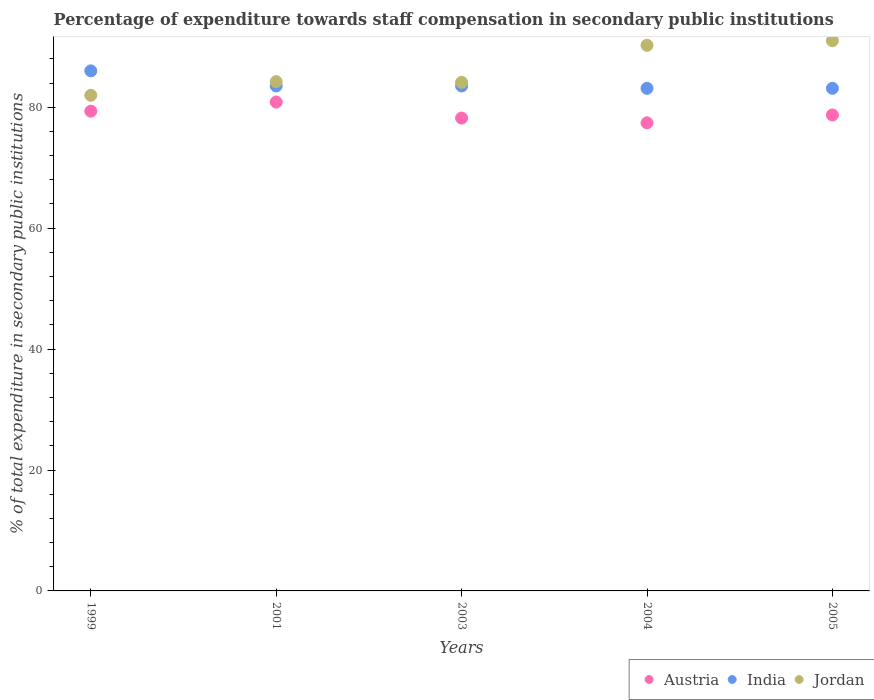What is the percentage of expenditure towards staff compensation in India in 1999?
Your answer should be very brief. 86.02. Across all years, what is the maximum percentage of expenditure towards staff compensation in Jordan?
Keep it short and to the point. 91.01. Across all years, what is the minimum percentage of expenditure towards staff compensation in Jordan?
Offer a terse response. 81.99. In which year was the percentage of expenditure towards staff compensation in Austria maximum?
Ensure brevity in your answer.  2001. In which year was the percentage of expenditure towards staff compensation in India minimum?
Make the answer very short. 2004. What is the total percentage of expenditure towards staff compensation in Austria in the graph?
Give a very brief answer. 394.57. What is the difference between the percentage of expenditure towards staff compensation in Jordan in 2001 and that in 2003?
Keep it short and to the point. 0.11. What is the difference between the percentage of expenditure towards staff compensation in Austria in 1999 and the percentage of expenditure towards staff compensation in Jordan in 2005?
Give a very brief answer. -11.66. What is the average percentage of expenditure towards staff compensation in Jordan per year?
Provide a short and direct response. 86.32. In the year 1999, what is the difference between the percentage of expenditure towards staff compensation in India and percentage of expenditure towards staff compensation in Austria?
Keep it short and to the point. 6.67. What is the ratio of the percentage of expenditure towards staff compensation in Jordan in 1999 to that in 2003?
Give a very brief answer. 0.97. Is the percentage of expenditure towards staff compensation in Austria in 1999 less than that in 2004?
Ensure brevity in your answer.  No. Is the difference between the percentage of expenditure towards staff compensation in India in 1999 and 2001 greater than the difference between the percentage of expenditure towards staff compensation in Austria in 1999 and 2001?
Keep it short and to the point. Yes. What is the difference between the highest and the second highest percentage of expenditure towards staff compensation in Jordan?
Ensure brevity in your answer.  0.77. What is the difference between the highest and the lowest percentage of expenditure towards staff compensation in Austria?
Ensure brevity in your answer.  3.44. Is the sum of the percentage of expenditure towards staff compensation in Austria in 2003 and 2004 greater than the maximum percentage of expenditure towards staff compensation in India across all years?
Ensure brevity in your answer.  Yes. Is it the case that in every year, the sum of the percentage of expenditure towards staff compensation in Jordan and percentage of expenditure towards staff compensation in India  is greater than the percentage of expenditure towards staff compensation in Austria?
Make the answer very short. Yes. Are the values on the major ticks of Y-axis written in scientific E-notation?
Give a very brief answer. No. Does the graph contain any zero values?
Offer a very short reply. No. Does the graph contain grids?
Give a very brief answer. No. How many legend labels are there?
Offer a terse response. 3. How are the legend labels stacked?
Keep it short and to the point. Horizontal. What is the title of the graph?
Keep it short and to the point. Percentage of expenditure towards staff compensation in secondary public institutions. What is the label or title of the Y-axis?
Provide a succinct answer. % of total expenditure in secondary public institutions. What is the % of total expenditure in secondary public institutions in Austria in 1999?
Your answer should be very brief. 79.35. What is the % of total expenditure in secondary public institutions of India in 1999?
Make the answer very short. 86.02. What is the % of total expenditure in secondary public institutions in Jordan in 1999?
Make the answer very short. 81.99. What is the % of total expenditure in secondary public institutions in Austria in 2001?
Keep it short and to the point. 80.86. What is the % of total expenditure in secondary public institutions of India in 2001?
Your answer should be very brief. 83.52. What is the % of total expenditure in secondary public institutions in Jordan in 2001?
Give a very brief answer. 84.24. What is the % of total expenditure in secondary public institutions in Austria in 2003?
Your response must be concise. 78.21. What is the % of total expenditure in secondary public institutions of India in 2003?
Your answer should be very brief. 83.52. What is the % of total expenditure in secondary public institutions of Jordan in 2003?
Keep it short and to the point. 84.13. What is the % of total expenditure in secondary public institutions in Austria in 2004?
Provide a short and direct response. 77.43. What is the % of total expenditure in secondary public institutions in India in 2004?
Keep it short and to the point. 83.13. What is the % of total expenditure in secondary public institutions in Jordan in 2004?
Provide a short and direct response. 90.25. What is the % of total expenditure in secondary public institutions of Austria in 2005?
Give a very brief answer. 78.72. What is the % of total expenditure in secondary public institutions in India in 2005?
Your response must be concise. 83.13. What is the % of total expenditure in secondary public institutions of Jordan in 2005?
Your answer should be compact. 91.01. Across all years, what is the maximum % of total expenditure in secondary public institutions in Austria?
Offer a terse response. 80.86. Across all years, what is the maximum % of total expenditure in secondary public institutions of India?
Make the answer very short. 86.02. Across all years, what is the maximum % of total expenditure in secondary public institutions of Jordan?
Offer a terse response. 91.01. Across all years, what is the minimum % of total expenditure in secondary public institutions in Austria?
Offer a very short reply. 77.43. Across all years, what is the minimum % of total expenditure in secondary public institutions of India?
Your answer should be very brief. 83.13. Across all years, what is the minimum % of total expenditure in secondary public institutions in Jordan?
Provide a succinct answer. 81.99. What is the total % of total expenditure in secondary public institutions of Austria in the graph?
Your answer should be compact. 394.57. What is the total % of total expenditure in secondary public institutions in India in the graph?
Your answer should be very brief. 419.33. What is the total % of total expenditure in secondary public institutions of Jordan in the graph?
Provide a succinct answer. 431.61. What is the difference between the % of total expenditure in secondary public institutions in Austria in 1999 and that in 2001?
Keep it short and to the point. -1.51. What is the difference between the % of total expenditure in secondary public institutions of India in 1999 and that in 2001?
Your response must be concise. 2.5. What is the difference between the % of total expenditure in secondary public institutions of Jordan in 1999 and that in 2001?
Make the answer very short. -2.25. What is the difference between the % of total expenditure in secondary public institutions in Austria in 1999 and that in 2003?
Provide a short and direct response. 1.14. What is the difference between the % of total expenditure in secondary public institutions of India in 1999 and that in 2003?
Your response must be concise. 2.5. What is the difference between the % of total expenditure in secondary public institutions in Jordan in 1999 and that in 2003?
Make the answer very short. -2.14. What is the difference between the % of total expenditure in secondary public institutions in Austria in 1999 and that in 2004?
Keep it short and to the point. 1.93. What is the difference between the % of total expenditure in secondary public institutions in India in 1999 and that in 2004?
Your answer should be compact. 2.89. What is the difference between the % of total expenditure in secondary public institutions of Jordan in 1999 and that in 2004?
Your answer should be compact. -8.26. What is the difference between the % of total expenditure in secondary public institutions of Austria in 1999 and that in 2005?
Your response must be concise. 0.63. What is the difference between the % of total expenditure in secondary public institutions of India in 1999 and that in 2005?
Ensure brevity in your answer.  2.89. What is the difference between the % of total expenditure in secondary public institutions in Jordan in 1999 and that in 2005?
Your answer should be compact. -9.03. What is the difference between the % of total expenditure in secondary public institutions of Austria in 2001 and that in 2003?
Provide a short and direct response. 2.65. What is the difference between the % of total expenditure in secondary public institutions in India in 2001 and that in 2003?
Your answer should be compact. 0. What is the difference between the % of total expenditure in secondary public institutions of Jordan in 2001 and that in 2003?
Keep it short and to the point. 0.11. What is the difference between the % of total expenditure in secondary public institutions of Austria in 2001 and that in 2004?
Your answer should be compact. 3.44. What is the difference between the % of total expenditure in secondary public institutions in India in 2001 and that in 2004?
Provide a succinct answer. 0.39. What is the difference between the % of total expenditure in secondary public institutions in Jordan in 2001 and that in 2004?
Your response must be concise. -6.01. What is the difference between the % of total expenditure in secondary public institutions in Austria in 2001 and that in 2005?
Give a very brief answer. 2.14. What is the difference between the % of total expenditure in secondary public institutions of India in 2001 and that in 2005?
Your answer should be very brief. 0.39. What is the difference between the % of total expenditure in secondary public institutions of Jordan in 2001 and that in 2005?
Provide a short and direct response. -6.78. What is the difference between the % of total expenditure in secondary public institutions in Austria in 2003 and that in 2004?
Ensure brevity in your answer.  0.79. What is the difference between the % of total expenditure in secondary public institutions in India in 2003 and that in 2004?
Keep it short and to the point. 0.39. What is the difference between the % of total expenditure in secondary public institutions in Jordan in 2003 and that in 2004?
Your response must be concise. -6.12. What is the difference between the % of total expenditure in secondary public institutions in Austria in 2003 and that in 2005?
Keep it short and to the point. -0.51. What is the difference between the % of total expenditure in secondary public institutions in India in 2003 and that in 2005?
Provide a succinct answer. 0.39. What is the difference between the % of total expenditure in secondary public institutions in Jordan in 2003 and that in 2005?
Provide a short and direct response. -6.89. What is the difference between the % of total expenditure in secondary public institutions of Austria in 2004 and that in 2005?
Ensure brevity in your answer.  -1.3. What is the difference between the % of total expenditure in secondary public institutions of Jordan in 2004 and that in 2005?
Keep it short and to the point. -0.77. What is the difference between the % of total expenditure in secondary public institutions in Austria in 1999 and the % of total expenditure in secondary public institutions in India in 2001?
Keep it short and to the point. -4.17. What is the difference between the % of total expenditure in secondary public institutions in Austria in 1999 and the % of total expenditure in secondary public institutions in Jordan in 2001?
Offer a terse response. -4.88. What is the difference between the % of total expenditure in secondary public institutions in India in 1999 and the % of total expenditure in secondary public institutions in Jordan in 2001?
Ensure brevity in your answer.  1.78. What is the difference between the % of total expenditure in secondary public institutions in Austria in 1999 and the % of total expenditure in secondary public institutions in India in 2003?
Your answer should be compact. -4.17. What is the difference between the % of total expenditure in secondary public institutions of Austria in 1999 and the % of total expenditure in secondary public institutions of Jordan in 2003?
Ensure brevity in your answer.  -4.77. What is the difference between the % of total expenditure in secondary public institutions in India in 1999 and the % of total expenditure in secondary public institutions in Jordan in 2003?
Offer a very short reply. 1.9. What is the difference between the % of total expenditure in secondary public institutions in Austria in 1999 and the % of total expenditure in secondary public institutions in India in 2004?
Keep it short and to the point. -3.78. What is the difference between the % of total expenditure in secondary public institutions of Austria in 1999 and the % of total expenditure in secondary public institutions of Jordan in 2004?
Keep it short and to the point. -10.89. What is the difference between the % of total expenditure in secondary public institutions of India in 1999 and the % of total expenditure in secondary public institutions of Jordan in 2004?
Keep it short and to the point. -4.23. What is the difference between the % of total expenditure in secondary public institutions of Austria in 1999 and the % of total expenditure in secondary public institutions of India in 2005?
Provide a succinct answer. -3.78. What is the difference between the % of total expenditure in secondary public institutions of Austria in 1999 and the % of total expenditure in secondary public institutions of Jordan in 2005?
Provide a short and direct response. -11.66. What is the difference between the % of total expenditure in secondary public institutions in India in 1999 and the % of total expenditure in secondary public institutions in Jordan in 2005?
Your answer should be very brief. -4.99. What is the difference between the % of total expenditure in secondary public institutions of Austria in 2001 and the % of total expenditure in secondary public institutions of India in 2003?
Keep it short and to the point. -2.66. What is the difference between the % of total expenditure in secondary public institutions of Austria in 2001 and the % of total expenditure in secondary public institutions of Jordan in 2003?
Offer a very short reply. -3.26. What is the difference between the % of total expenditure in secondary public institutions of India in 2001 and the % of total expenditure in secondary public institutions of Jordan in 2003?
Ensure brevity in your answer.  -0.6. What is the difference between the % of total expenditure in secondary public institutions of Austria in 2001 and the % of total expenditure in secondary public institutions of India in 2004?
Give a very brief answer. -2.27. What is the difference between the % of total expenditure in secondary public institutions of Austria in 2001 and the % of total expenditure in secondary public institutions of Jordan in 2004?
Your answer should be compact. -9.38. What is the difference between the % of total expenditure in secondary public institutions in India in 2001 and the % of total expenditure in secondary public institutions in Jordan in 2004?
Ensure brevity in your answer.  -6.72. What is the difference between the % of total expenditure in secondary public institutions in Austria in 2001 and the % of total expenditure in secondary public institutions in India in 2005?
Your answer should be compact. -2.27. What is the difference between the % of total expenditure in secondary public institutions of Austria in 2001 and the % of total expenditure in secondary public institutions of Jordan in 2005?
Your answer should be very brief. -10.15. What is the difference between the % of total expenditure in secondary public institutions of India in 2001 and the % of total expenditure in secondary public institutions of Jordan in 2005?
Offer a very short reply. -7.49. What is the difference between the % of total expenditure in secondary public institutions of Austria in 2003 and the % of total expenditure in secondary public institutions of India in 2004?
Offer a very short reply. -4.92. What is the difference between the % of total expenditure in secondary public institutions of Austria in 2003 and the % of total expenditure in secondary public institutions of Jordan in 2004?
Offer a terse response. -12.03. What is the difference between the % of total expenditure in secondary public institutions of India in 2003 and the % of total expenditure in secondary public institutions of Jordan in 2004?
Give a very brief answer. -6.72. What is the difference between the % of total expenditure in secondary public institutions in Austria in 2003 and the % of total expenditure in secondary public institutions in India in 2005?
Provide a short and direct response. -4.92. What is the difference between the % of total expenditure in secondary public institutions of Austria in 2003 and the % of total expenditure in secondary public institutions of Jordan in 2005?
Provide a succinct answer. -12.8. What is the difference between the % of total expenditure in secondary public institutions of India in 2003 and the % of total expenditure in secondary public institutions of Jordan in 2005?
Provide a short and direct response. -7.49. What is the difference between the % of total expenditure in secondary public institutions in Austria in 2004 and the % of total expenditure in secondary public institutions in India in 2005?
Your answer should be very brief. -5.71. What is the difference between the % of total expenditure in secondary public institutions of Austria in 2004 and the % of total expenditure in secondary public institutions of Jordan in 2005?
Make the answer very short. -13.59. What is the difference between the % of total expenditure in secondary public institutions of India in 2004 and the % of total expenditure in secondary public institutions of Jordan in 2005?
Provide a succinct answer. -7.88. What is the average % of total expenditure in secondary public institutions in Austria per year?
Provide a short and direct response. 78.91. What is the average % of total expenditure in secondary public institutions of India per year?
Provide a succinct answer. 83.87. What is the average % of total expenditure in secondary public institutions of Jordan per year?
Give a very brief answer. 86.32. In the year 1999, what is the difference between the % of total expenditure in secondary public institutions of Austria and % of total expenditure in secondary public institutions of India?
Keep it short and to the point. -6.67. In the year 1999, what is the difference between the % of total expenditure in secondary public institutions in Austria and % of total expenditure in secondary public institutions in Jordan?
Give a very brief answer. -2.64. In the year 1999, what is the difference between the % of total expenditure in secondary public institutions in India and % of total expenditure in secondary public institutions in Jordan?
Offer a terse response. 4.03. In the year 2001, what is the difference between the % of total expenditure in secondary public institutions of Austria and % of total expenditure in secondary public institutions of India?
Your response must be concise. -2.66. In the year 2001, what is the difference between the % of total expenditure in secondary public institutions of Austria and % of total expenditure in secondary public institutions of Jordan?
Keep it short and to the point. -3.37. In the year 2001, what is the difference between the % of total expenditure in secondary public institutions of India and % of total expenditure in secondary public institutions of Jordan?
Your answer should be compact. -0.71. In the year 2003, what is the difference between the % of total expenditure in secondary public institutions in Austria and % of total expenditure in secondary public institutions in India?
Ensure brevity in your answer.  -5.31. In the year 2003, what is the difference between the % of total expenditure in secondary public institutions of Austria and % of total expenditure in secondary public institutions of Jordan?
Provide a short and direct response. -5.91. In the year 2003, what is the difference between the % of total expenditure in secondary public institutions of India and % of total expenditure in secondary public institutions of Jordan?
Provide a succinct answer. -0.6. In the year 2004, what is the difference between the % of total expenditure in secondary public institutions in Austria and % of total expenditure in secondary public institutions in India?
Your answer should be very brief. -5.71. In the year 2004, what is the difference between the % of total expenditure in secondary public institutions of Austria and % of total expenditure in secondary public institutions of Jordan?
Ensure brevity in your answer.  -12.82. In the year 2004, what is the difference between the % of total expenditure in secondary public institutions of India and % of total expenditure in secondary public institutions of Jordan?
Make the answer very short. -7.12. In the year 2005, what is the difference between the % of total expenditure in secondary public institutions in Austria and % of total expenditure in secondary public institutions in India?
Your response must be concise. -4.41. In the year 2005, what is the difference between the % of total expenditure in secondary public institutions of Austria and % of total expenditure in secondary public institutions of Jordan?
Offer a terse response. -12.29. In the year 2005, what is the difference between the % of total expenditure in secondary public institutions of India and % of total expenditure in secondary public institutions of Jordan?
Keep it short and to the point. -7.88. What is the ratio of the % of total expenditure in secondary public institutions in Austria in 1999 to that in 2001?
Ensure brevity in your answer.  0.98. What is the ratio of the % of total expenditure in secondary public institutions of India in 1999 to that in 2001?
Provide a short and direct response. 1.03. What is the ratio of the % of total expenditure in secondary public institutions of Jordan in 1999 to that in 2001?
Your answer should be compact. 0.97. What is the ratio of the % of total expenditure in secondary public institutions of Austria in 1999 to that in 2003?
Provide a succinct answer. 1.01. What is the ratio of the % of total expenditure in secondary public institutions in India in 1999 to that in 2003?
Make the answer very short. 1.03. What is the ratio of the % of total expenditure in secondary public institutions of Jordan in 1999 to that in 2003?
Make the answer very short. 0.97. What is the ratio of the % of total expenditure in secondary public institutions in Austria in 1999 to that in 2004?
Offer a very short reply. 1.02. What is the ratio of the % of total expenditure in secondary public institutions of India in 1999 to that in 2004?
Make the answer very short. 1.03. What is the ratio of the % of total expenditure in secondary public institutions of Jordan in 1999 to that in 2004?
Ensure brevity in your answer.  0.91. What is the ratio of the % of total expenditure in secondary public institutions of Austria in 1999 to that in 2005?
Ensure brevity in your answer.  1.01. What is the ratio of the % of total expenditure in secondary public institutions of India in 1999 to that in 2005?
Your response must be concise. 1.03. What is the ratio of the % of total expenditure in secondary public institutions in Jordan in 1999 to that in 2005?
Your answer should be compact. 0.9. What is the ratio of the % of total expenditure in secondary public institutions of Austria in 2001 to that in 2003?
Give a very brief answer. 1.03. What is the ratio of the % of total expenditure in secondary public institutions in Austria in 2001 to that in 2004?
Your response must be concise. 1.04. What is the ratio of the % of total expenditure in secondary public institutions in India in 2001 to that in 2004?
Provide a short and direct response. 1. What is the ratio of the % of total expenditure in secondary public institutions of Jordan in 2001 to that in 2004?
Ensure brevity in your answer.  0.93. What is the ratio of the % of total expenditure in secondary public institutions of Austria in 2001 to that in 2005?
Keep it short and to the point. 1.03. What is the ratio of the % of total expenditure in secondary public institutions of Jordan in 2001 to that in 2005?
Offer a very short reply. 0.93. What is the ratio of the % of total expenditure in secondary public institutions in Austria in 2003 to that in 2004?
Give a very brief answer. 1.01. What is the ratio of the % of total expenditure in secondary public institutions of Jordan in 2003 to that in 2004?
Provide a succinct answer. 0.93. What is the ratio of the % of total expenditure in secondary public institutions of Austria in 2003 to that in 2005?
Make the answer very short. 0.99. What is the ratio of the % of total expenditure in secondary public institutions in Jordan in 2003 to that in 2005?
Your response must be concise. 0.92. What is the ratio of the % of total expenditure in secondary public institutions of Austria in 2004 to that in 2005?
Keep it short and to the point. 0.98. What is the ratio of the % of total expenditure in secondary public institutions in India in 2004 to that in 2005?
Provide a short and direct response. 1. What is the difference between the highest and the second highest % of total expenditure in secondary public institutions in Austria?
Offer a very short reply. 1.51. What is the difference between the highest and the second highest % of total expenditure in secondary public institutions of India?
Offer a terse response. 2.5. What is the difference between the highest and the second highest % of total expenditure in secondary public institutions of Jordan?
Your answer should be very brief. 0.77. What is the difference between the highest and the lowest % of total expenditure in secondary public institutions of Austria?
Ensure brevity in your answer.  3.44. What is the difference between the highest and the lowest % of total expenditure in secondary public institutions in India?
Offer a very short reply. 2.89. What is the difference between the highest and the lowest % of total expenditure in secondary public institutions of Jordan?
Your answer should be very brief. 9.03. 